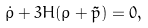<formula> <loc_0><loc_0><loc_500><loc_500>\dot { \rho } + 3 H ( \rho + \tilde { p } ) = 0 ,</formula> 